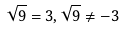Convert formula to latex. <formula><loc_0><loc_0><loc_500><loc_500>\sqrt { 9 } = 3 , \sqrt { 9 } \ne - 3</formula> 